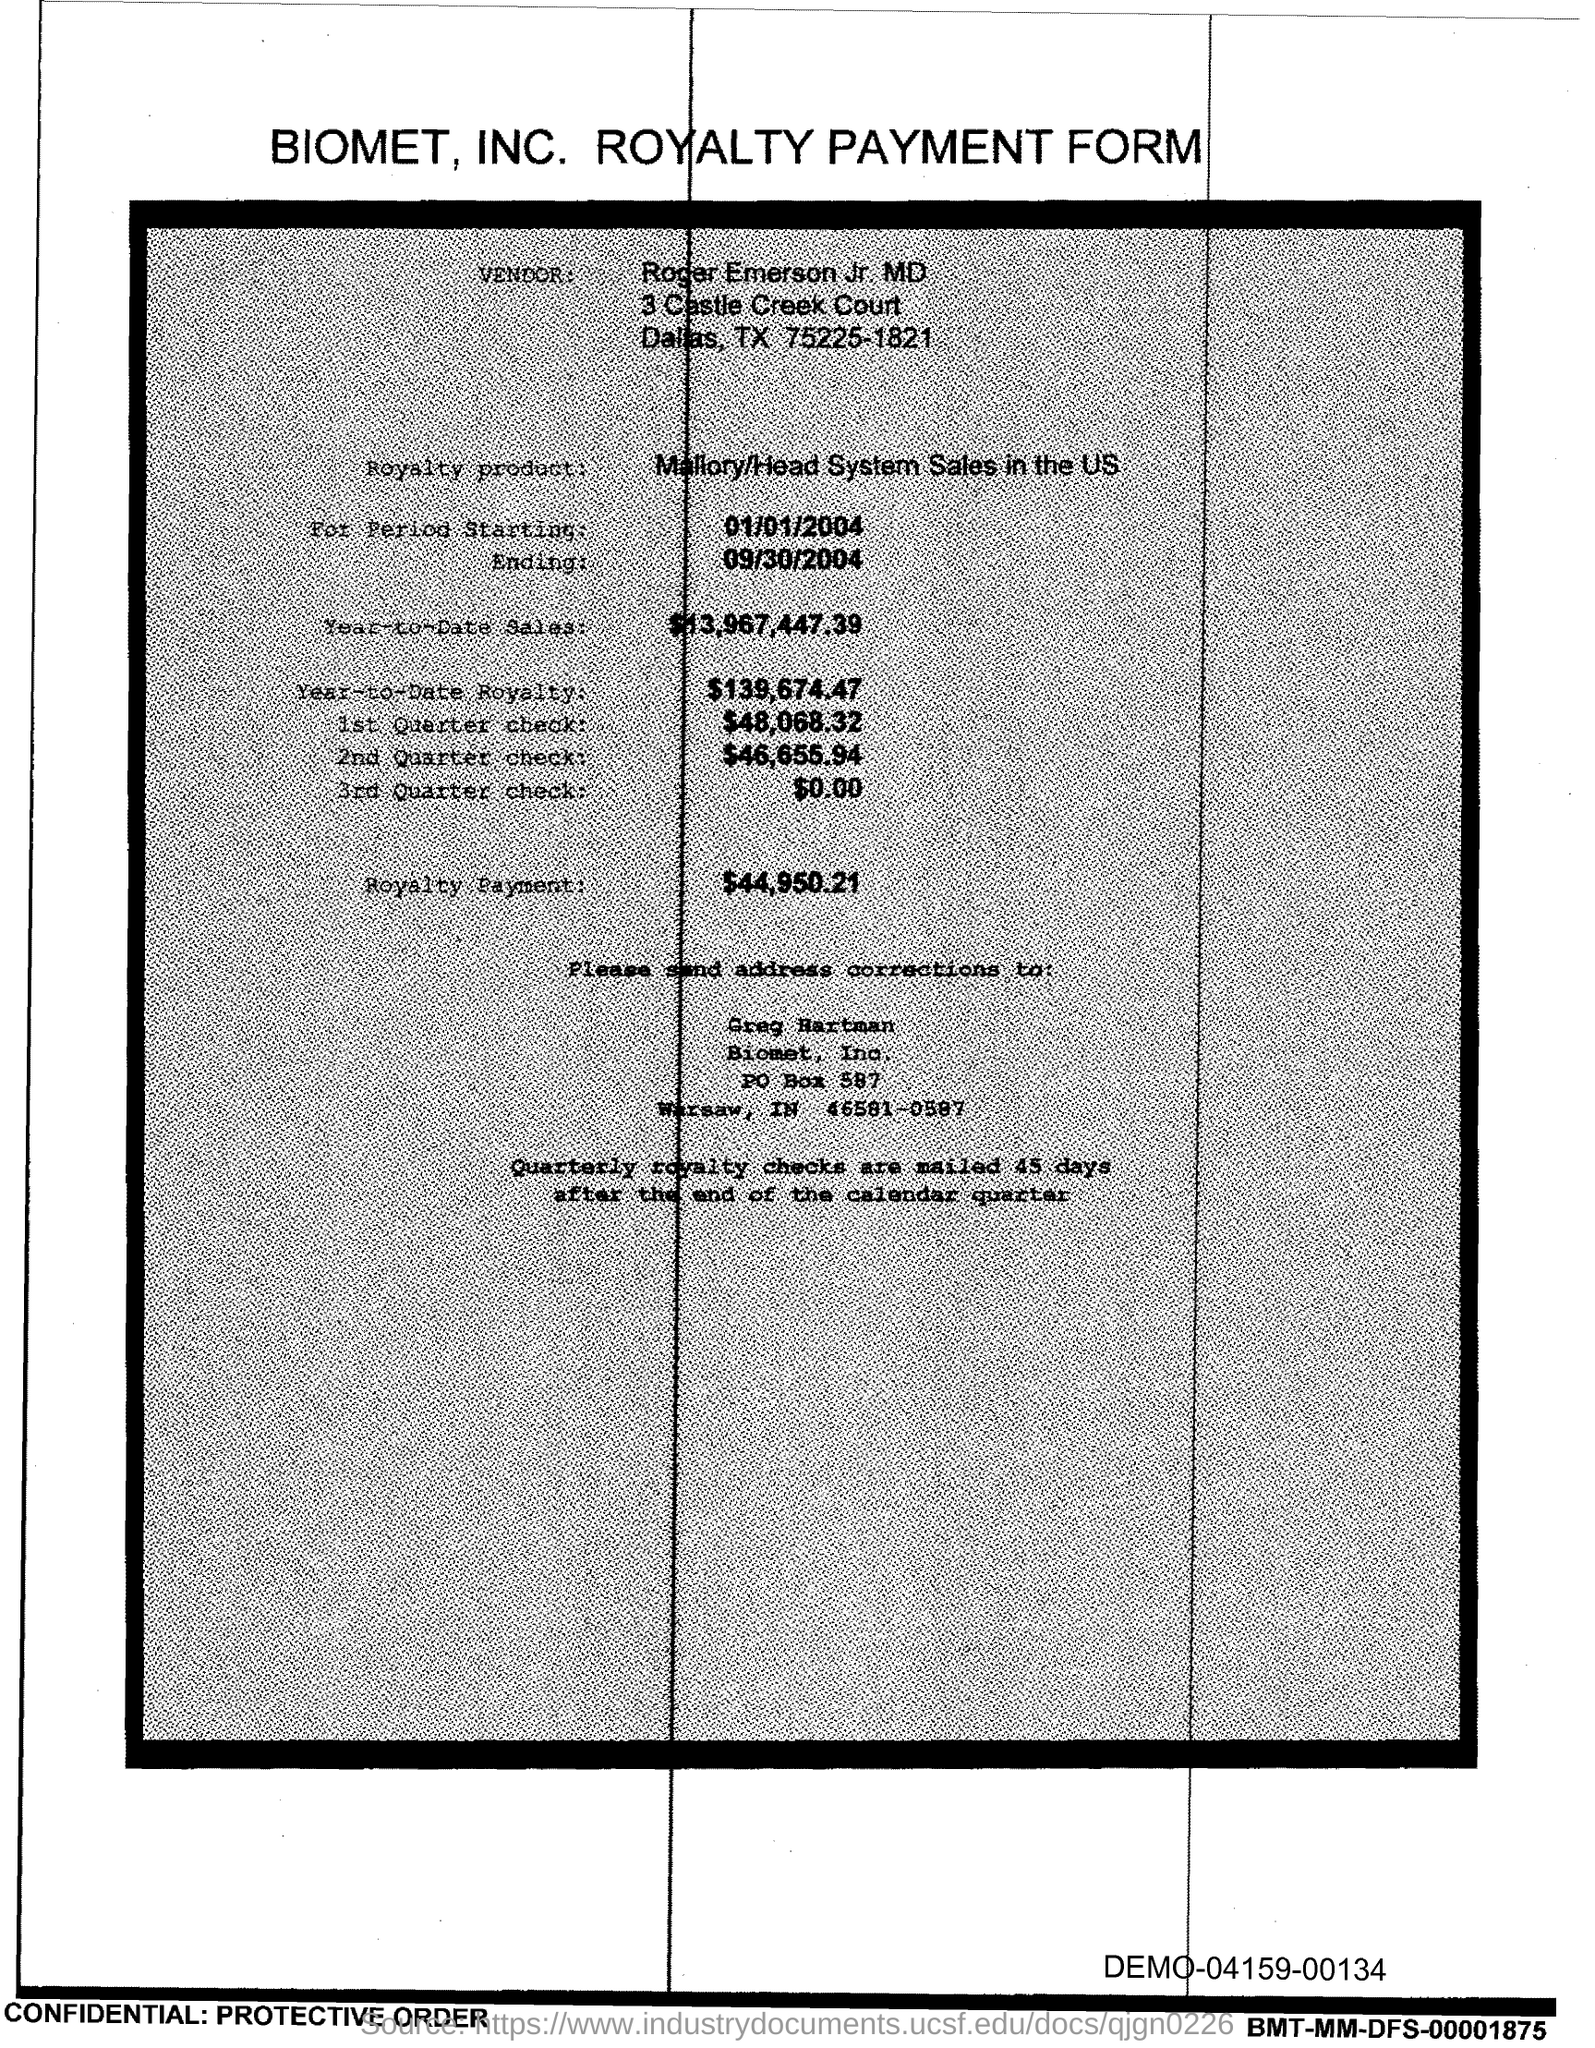List a handful of essential elements in this visual. The address corrections should be sent to Greg Hartman. The royalty product, known as Mallory/Head System Sales in the US, is a system used to calculate royalty payments for the use of intellectual property. The vendor name is Roger Emerson Jr. MD. This is a royalty payment form. The city from which the vendor hails is Dallas. 